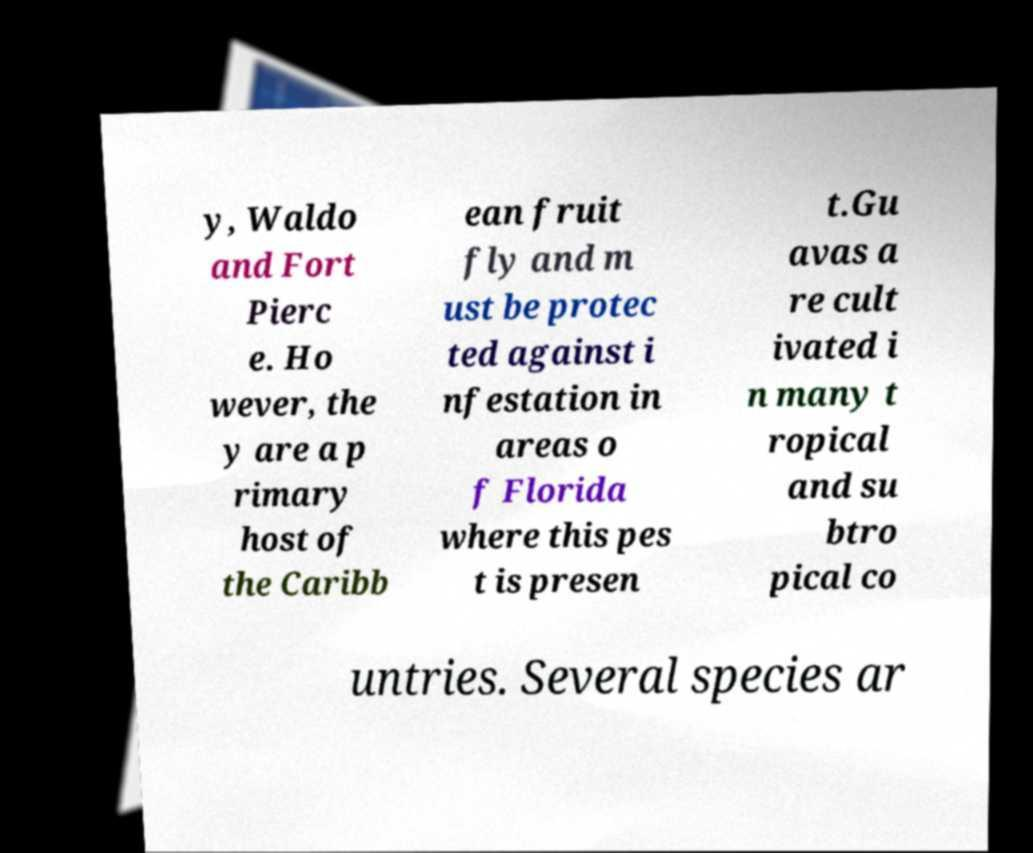There's text embedded in this image that I need extracted. Can you transcribe it verbatim? y, Waldo and Fort Pierc e. Ho wever, the y are a p rimary host of the Caribb ean fruit fly and m ust be protec ted against i nfestation in areas o f Florida where this pes t is presen t.Gu avas a re cult ivated i n many t ropical and su btro pical co untries. Several species ar 